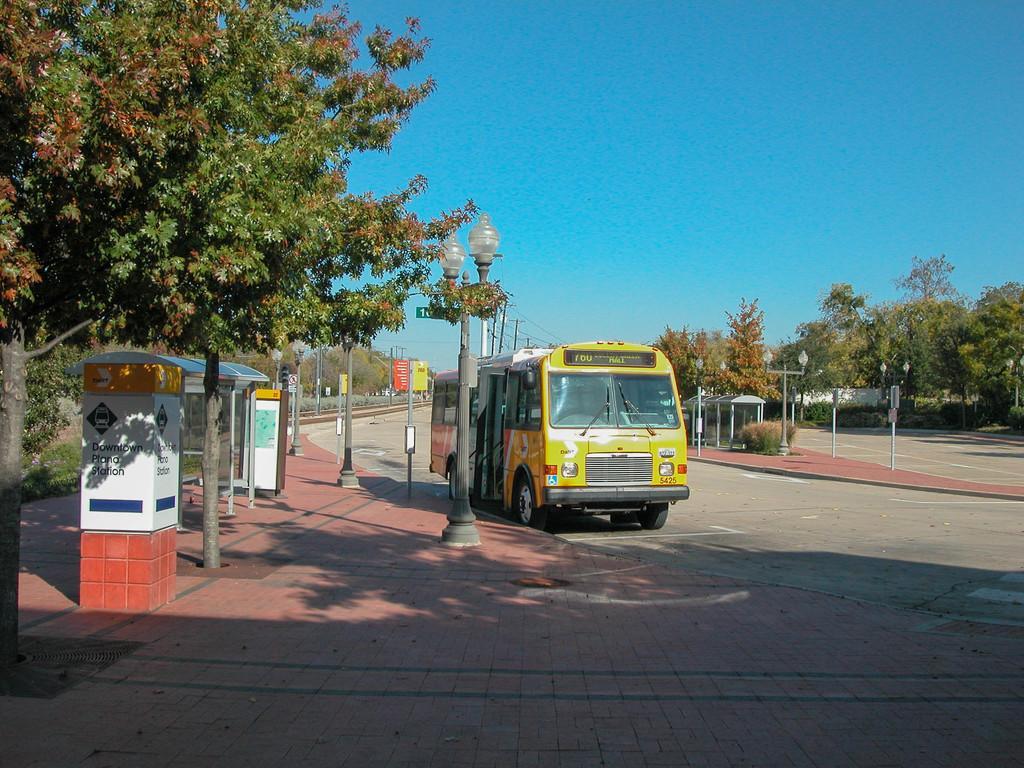In one or two sentences, can you explain what this image depicts? In the center of the image there is a bus on the road. On the right side of the image there are sign boards, trees and poles. On the left side of the image we can see light poles, shelter and trees. In the background there are trees and sky. 